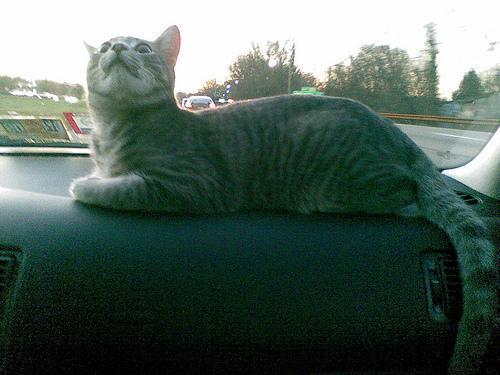How many cats are there?
Give a very brief answer. 1. How many eyes does the cat have?
Give a very brief answer. 2. 